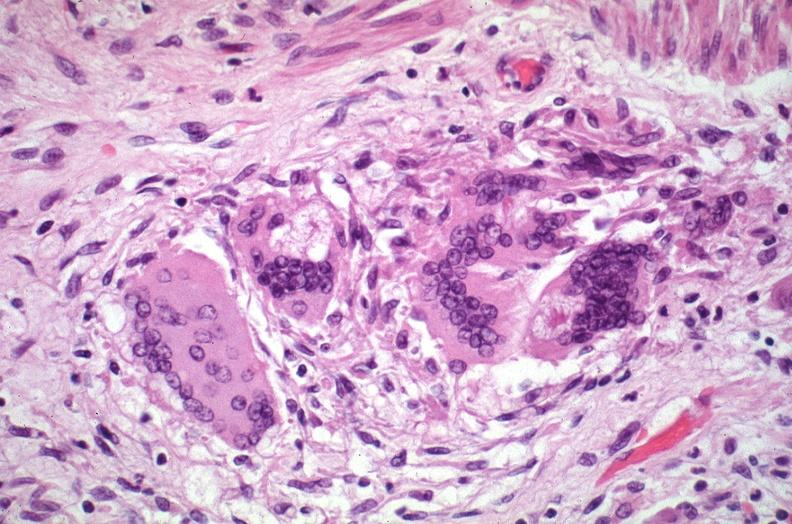what is present?
Answer the question using a single word or phrase. Respiratory 